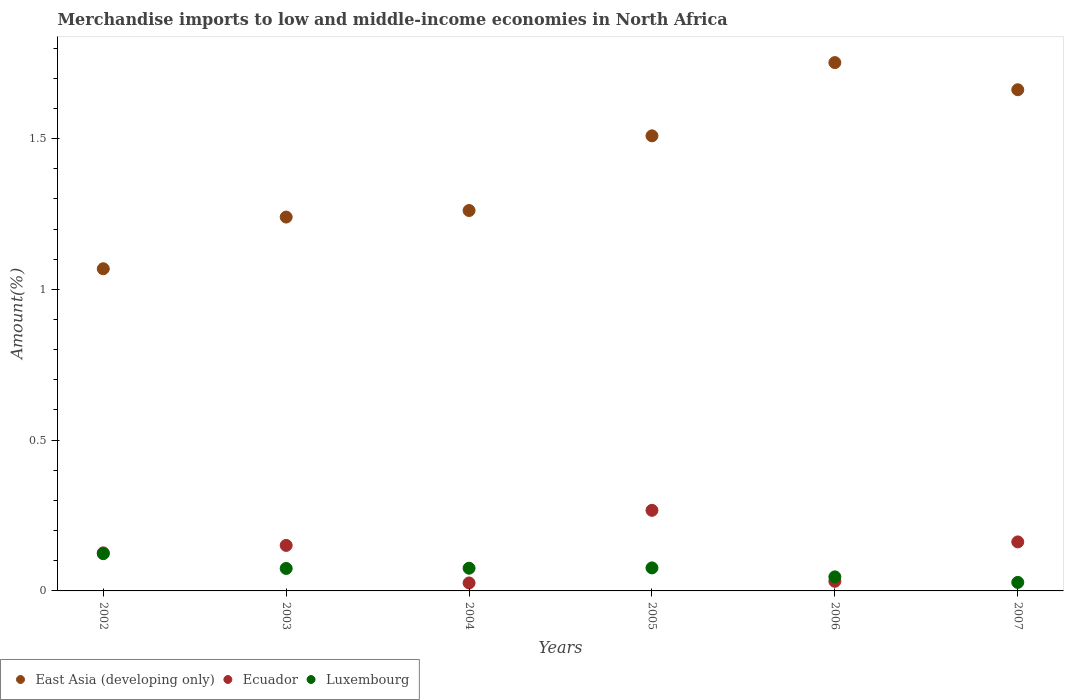How many different coloured dotlines are there?
Ensure brevity in your answer.  3. Is the number of dotlines equal to the number of legend labels?
Make the answer very short. Yes. What is the percentage of amount earned from merchandise imports in Luxembourg in 2002?
Your response must be concise. 0.12. Across all years, what is the maximum percentage of amount earned from merchandise imports in East Asia (developing only)?
Provide a short and direct response. 1.75. Across all years, what is the minimum percentage of amount earned from merchandise imports in Ecuador?
Ensure brevity in your answer.  0.03. In which year was the percentage of amount earned from merchandise imports in East Asia (developing only) maximum?
Your response must be concise. 2006. What is the total percentage of amount earned from merchandise imports in Ecuador in the graph?
Your answer should be very brief. 0.77. What is the difference between the percentage of amount earned from merchandise imports in Ecuador in 2004 and that in 2007?
Provide a succinct answer. -0.14. What is the difference between the percentage of amount earned from merchandise imports in Luxembourg in 2004 and the percentage of amount earned from merchandise imports in East Asia (developing only) in 2002?
Provide a succinct answer. -0.99. What is the average percentage of amount earned from merchandise imports in Luxembourg per year?
Offer a terse response. 0.07. In the year 2004, what is the difference between the percentage of amount earned from merchandise imports in Ecuador and percentage of amount earned from merchandise imports in East Asia (developing only)?
Make the answer very short. -1.24. In how many years, is the percentage of amount earned from merchandise imports in Ecuador greater than 0.9 %?
Provide a short and direct response. 0. What is the ratio of the percentage of amount earned from merchandise imports in Luxembourg in 2003 to that in 2006?
Provide a succinct answer. 1.6. What is the difference between the highest and the second highest percentage of amount earned from merchandise imports in Luxembourg?
Give a very brief answer. 0.05. What is the difference between the highest and the lowest percentage of amount earned from merchandise imports in Luxembourg?
Your answer should be very brief. 0.1. In how many years, is the percentage of amount earned from merchandise imports in East Asia (developing only) greater than the average percentage of amount earned from merchandise imports in East Asia (developing only) taken over all years?
Your answer should be very brief. 3. Is it the case that in every year, the sum of the percentage of amount earned from merchandise imports in East Asia (developing only) and percentage of amount earned from merchandise imports in Luxembourg  is greater than the percentage of amount earned from merchandise imports in Ecuador?
Provide a succinct answer. Yes. Is the percentage of amount earned from merchandise imports in Ecuador strictly greater than the percentage of amount earned from merchandise imports in Luxembourg over the years?
Your answer should be compact. No. Is the percentage of amount earned from merchandise imports in Luxembourg strictly less than the percentage of amount earned from merchandise imports in East Asia (developing only) over the years?
Offer a terse response. Yes. What is the difference between two consecutive major ticks on the Y-axis?
Your response must be concise. 0.5. Does the graph contain any zero values?
Your answer should be compact. No. How many legend labels are there?
Give a very brief answer. 3. How are the legend labels stacked?
Your response must be concise. Horizontal. What is the title of the graph?
Offer a very short reply. Merchandise imports to low and middle-income economies in North Africa. Does "Arab World" appear as one of the legend labels in the graph?
Offer a terse response. No. What is the label or title of the Y-axis?
Offer a terse response. Amount(%). What is the Amount(%) in East Asia (developing only) in 2002?
Offer a terse response. 1.07. What is the Amount(%) of Ecuador in 2002?
Offer a very short reply. 0.13. What is the Amount(%) in Luxembourg in 2002?
Provide a short and direct response. 0.12. What is the Amount(%) in East Asia (developing only) in 2003?
Provide a succinct answer. 1.24. What is the Amount(%) in Ecuador in 2003?
Offer a terse response. 0.15. What is the Amount(%) in Luxembourg in 2003?
Ensure brevity in your answer.  0.07. What is the Amount(%) in East Asia (developing only) in 2004?
Offer a terse response. 1.26. What is the Amount(%) in Ecuador in 2004?
Your response must be concise. 0.03. What is the Amount(%) in Luxembourg in 2004?
Offer a very short reply. 0.08. What is the Amount(%) of East Asia (developing only) in 2005?
Keep it short and to the point. 1.51. What is the Amount(%) of Ecuador in 2005?
Offer a very short reply. 0.27. What is the Amount(%) of Luxembourg in 2005?
Provide a succinct answer. 0.08. What is the Amount(%) in East Asia (developing only) in 2006?
Your answer should be compact. 1.75. What is the Amount(%) in Ecuador in 2006?
Make the answer very short. 0.03. What is the Amount(%) in Luxembourg in 2006?
Make the answer very short. 0.05. What is the Amount(%) in East Asia (developing only) in 2007?
Provide a short and direct response. 1.66. What is the Amount(%) in Ecuador in 2007?
Offer a very short reply. 0.16. What is the Amount(%) in Luxembourg in 2007?
Provide a short and direct response. 0.03. Across all years, what is the maximum Amount(%) of East Asia (developing only)?
Offer a very short reply. 1.75. Across all years, what is the maximum Amount(%) in Ecuador?
Your answer should be compact. 0.27. Across all years, what is the maximum Amount(%) of Luxembourg?
Make the answer very short. 0.12. Across all years, what is the minimum Amount(%) in East Asia (developing only)?
Offer a very short reply. 1.07. Across all years, what is the minimum Amount(%) in Ecuador?
Your answer should be very brief. 0.03. Across all years, what is the minimum Amount(%) of Luxembourg?
Offer a very short reply. 0.03. What is the total Amount(%) in East Asia (developing only) in the graph?
Give a very brief answer. 8.49. What is the total Amount(%) of Ecuador in the graph?
Your answer should be compact. 0.77. What is the total Amount(%) in Luxembourg in the graph?
Keep it short and to the point. 0.42. What is the difference between the Amount(%) in East Asia (developing only) in 2002 and that in 2003?
Give a very brief answer. -0.17. What is the difference between the Amount(%) in Ecuador in 2002 and that in 2003?
Ensure brevity in your answer.  -0.02. What is the difference between the Amount(%) of Luxembourg in 2002 and that in 2003?
Your response must be concise. 0.05. What is the difference between the Amount(%) of East Asia (developing only) in 2002 and that in 2004?
Provide a short and direct response. -0.19. What is the difference between the Amount(%) of Ecuador in 2002 and that in 2004?
Your response must be concise. 0.1. What is the difference between the Amount(%) of Luxembourg in 2002 and that in 2004?
Your response must be concise. 0.05. What is the difference between the Amount(%) in East Asia (developing only) in 2002 and that in 2005?
Provide a succinct answer. -0.44. What is the difference between the Amount(%) in Ecuador in 2002 and that in 2005?
Your answer should be compact. -0.14. What is the difference between the Amount(%) in Luxembourg in 2002 and that in 2005?
Your answer should be compact. 0.05. What is the difference between the Amount(%) in East Asia (developing only) in 2002 and that in 2006?
Your answer should be very brief. -0.68. What is the difference between the Amount(%) in Ecuador in 2002 and that in 2006?
Ensure brevity in your answer.  0.09. What is the difference between the Amount(%) in Luxembourg in 2002 and that in 2006?
Ensure brevity in your answer.  0.08. What is the difference between the Amount(%) in East Asia (developing only) in 2002 and that in 2007?
Offer a terse response. -0.59. What is the difference between the Amount(%) in Ecuador in 2002 and that in 2007?
Your answer should be compact. -0.04. What is the difference between the Amount(%) in Luxembourg in 2002 and that in 2007?
Offer a very short reply. 0.1. What is the difference between the Amount(%) in East Asia (developing only) in 2003 and that in 2004?
Keep it short and to the point. -0.02. What is the difference between the Amount(%) of Ecuador in 2003 and that in 2004?
Make the answer very short. 0.12. What is the difference between the Amount(%) in Luxembourg in 2003 and that in 2004?
Your response must be concise. -0. What is the difference between the Amount(%) of East Asia (developing only) in 2003 and that in 2005?
Make the answer very short. -0.27. What is the difference between the Amount(%) in Ecuador in 2003 and that in 2005?
Your answer should be very brief. -0.12. What is the difference between the Amount(%) in Luxembourg in 2003 and that in 2005?
Your response must be concise. -0. What is the difference between the Amount(%) of East Asia (developing only) in 2003 and that in 2006?
Offer a terse response. -0.51. What is the difference between the Amount(%) of Ecuador in 2003 and that in 2006?
Provide a succinct answer. 0.12. What is the difference between the Amount(%) of Luxembourg in 2003 and that in 2006?
Offer a terse response. 0.03. What is the difference between the Amount(%) in East Asia (developing only) in 2003 and that in 2007?
Offer a very short reply. -0.42. What is the difference between the Amount(%) in Ecuador in 2003 and that in 2007?
Your answer should be very brief. -0.01. What is the difference between the Amount(%) of Luxembourg in 2003 and that in 2007?
Offer a very short reply. 0.05. What is the difference between the Amount(%) of East Asia (developing only) in 2004 and that in 2005?
Your answer should be very brief. -0.25. What is the difference between the Amount(%) of Ecuador in 2004 and that in 2005?
Your response must be concise. -0.24. What is the difference between the Amount(%) of Luxembourg in 2004 and that in 2005?
Keep it short and to the point. -0. What is the difference between the Amount(%) in East Asia (developing only) in 2004 and that in 2006?
Give a very brief answer. -0.49. What is the difference between the Amount(%) in Ecuador in 2004 and that in 2006?
Provide a short and direct response. -0.01. What is the difference between the Amount(%) in Luxembourg in 2004 and that in 2006?
Ensure brevity in your answer.  0.03. What is the difference between the Amount(%) of East Asia (developing only) in 2004 and that in 2007?
Offer a very short reply. -0.4. What is the difference between the Amount(%) of Ecuador in 2004 and that in 2007?
Ensure brevity in your answer.  -0.14. What is the difference between the Amount(%) of Luxembourg in 2004 and that in 2007?
Offer a very short reply. 0.05. What is the difference between the Amount(%) of East Asia (developing only) in 2005 and that in 2006?
Keep it short and to the point. -0.24. What is the difference between the Amount(%) in Ecuador in 2005 and that in 2006?
Offer a terse response. 0.24. What is the difference between the Amount(%) of Luxembourg in 2005 and that in 2006?
Your response must be concise. 0.03. What is the difference between the Amount(%) in East Asia (developing only) in 2005 and that in 2007?
Ensure brevity in your answer.  -0.15. What is the difference between the Amount(%) of Ecuador in 2005 and that in 2007?
Give a very brief answer. 0.1. What is the difference between the Amount(%) of Luxembourg in 2005 and that in 2007?
Keep it short and to the point. 0.05. What is the difference between the Amount(%) in East Asia (developing only) in 2006 and that in 2007?
Your response must be concise. 0.09. What is the difference between the Amount(%) in Ecuador in 2006 and that in 2007?
Your answer should be compact. -0.13. What is the difference between the Amount(%) in Luxembourg in 2006 and that in 2007?
Offer a terse response. 0.02. What is the difference between the Amount(%) of East Asia (developing only) in 2002 and the Amount(%) of Ecuador in 2003?
Your answer should be compact. 0.92. What is the difference between the Amount(%) in Ecuador in 2002 and the Amount(%) in Luxembourg in 2003?
Make the answer very short. 0.05. What is the difference between the Amount(%) in East Asia (developing only) in 2002 and the Amount(%) in Ecuador in 2004?
Offer a very short reply. 1.04. What is the difference between the Amount(%) of East Asia (developing only) in 2002 and the Amount(%) of Luxembourg in 2004?
Keep it short and to the point. 0.99. What is the difference between the Amount(%) of Ecuador in 2002 and the Amount(%) of Luxembourg in 2004?
Your answer should be compact. 0.05. What is the difference between the Amount(%) in East Asia (developing only) in 2002 and the Amount(%) in Ecuador in 2005?
Offer a very short reply. 0.8. What is the difference between the Amount(%) of East Asia (developing only) in 2002 and the Amount(%) of Luxembourg in 2005?
Your answer should be compact. 0.99. What is the difference between the Amount(%) of Ecuador in 2002 and the Amount(%) of Luxembourg in 2005?
Your answer should be compact. 0.05. What is the difference between the Amount(%) in East Asia (developing only) in 2002 and the Amount(%) in Ecuador in 2006?
Ensure brevity in your answer.  1.04. What is the difference between the Amount(%) in East Asia (developing only) in 2002 and the Amount(%) in Luxembourg in 2006?
Ensure brevity in your answer.  1.02. What is the difference between the Amount(%) in Ecuador in 2002 and the Amount(%) in Luxembourg in 2006?
Make the answer very short. 0.08. What is the difference between the Amount(%) of East Asia (developing only) in 2002 and the Amount(%) of Ecuador in 2007?
Provide a succinct answer. 0.91. What is the difference between the Amount(%) in East Asia (developing only) in 2002 and the Amount(%) in Luxembourg in 2007?
Offer a terse response. 1.04. What is the difference between the Amount(%) of Ecuador in 2002 and the Amount(%) of Luxembourg in 2007?
Offer a very short reply. 0.1. What is the difference between the Amount(%) of East Asia (developing only) in 2003 and the Amount(%) of Ecuador in 2004?
Make the answer very short. 1.21. What is the difference between the Amount(%) of East Asia (developing only) in 2003 and the Amount(%) of Luxembourg in 2004?
Your response must be concise. 1.16. What is the difference between the Amount(%) in Ecuador in 2003 and the Amount(%) in Luxembourg in 2004?
Provide a short and direct response. 0.08. What is the difference between the Amount(%) in East Asia (developing only) in 2003 and the Amount(%) in Ecuador in 2005?
Your answer should be very brief. 0.97. What is the difference between the Amount(%) in East Asia (developing only) in 2003 and the Amount(%) in Luxembourg in 2005?
Ensure brevity in your answer.  1.16. What is the difference between the Amount(%) in Ecuador in 2003 and the Amount(%) in Luxembourg in 2005?
Ensure brevity in your answer.  0.07. What is the difference between the Amount(%) in East Asia (developing only) in 2003 and the Amount(%) in Ecuador in 2006?
Your answer should be very brief. 1.21. What is the difference between the Amount(%) of East Asia (developing only) in 2003 and the Amount(%) of Luxembourg in 2006?
Your response must be concise. 1.19. What is the difference between the Amount(%) in Ecuador in 2003 and the Amount(%) in Luxembourg in 2006?
Offer a very short reply. 0.1. What is the difference between the Amount(%) of East Asia (developing only) in 2003 and the Amount(%) of Ecuador in 2007?
Provide a succinct answer. 1.08. What is the difference between the Amount(%) in East Asia (developing only) in 2003 and the Amount(%) in Luxembourg in 2007?
Offer a terse response. 1.21. What is the difference between the Amount(%) of Ecuador in 2003 and the Amount(%) of Luxembourg in 2007?
Make the answer very short. 0.12. What is the difference between the Amount(%) in East Asia (developing only) in 2004 and the Amount(%) in Luxembourg in 2005?
Offer a very short reply. 1.19. What is the difference between the Amount(%) of Ecuador in 2004 and the Amount(%) of Luxembourg in 2005?
Your answer should be very brief. -0.05. What is the difference between the Amount(%) in East Asia (developing only) in 2004 and the Amount(%) in Ecuador in 2006?
Ensure brevity in your answer.  1.23. What is the difference between the Amount(%) in East Asia (developing only) in 2004 and the Amount(%) in Luxembourg in 2006?
Offer a terse response. 1.21. What is the difference between the Amount(%) in Ecuador in 2004 and the Amount(%) in Luxembourg in 2006?
Your response must be concise. -0.02. What is the difference between the Amount(%) of East Asia (developing only) in 2004 and the Amount(%) of Ecuador in 2007?
Your answer should be compact. 1.1. What is the difference between the Amount(%) in East Asia (developing only) in 2004 and the Amount(%) in Luxembourg in 2007?
Provide a short and direct response. 1.23. What is the difference between the Amount(%) of Ecuador in 2004 and the Amount(%) of Luxembourg in 2007?
Provide a short and direct response. -0. What is the difference between the Amount(%) of East Asia (developing only) in 2005 and the Amount(%) of Ecuador in 2006?
Give a very brief answer. 1.48. What is the difference between the Amount(%) in East Asia (developing only) in 2005 and the Amount(%) in Luxembourg in 2006?
Provide a succinct answer. 1.46. What is the difference between the Amount(%) of Ecuador in 2005 and the Amount(%) of Luxembourg in 2006?
Provide a succinct answer. 0.22. What is the difference between the Amount(%) in East Asia (developing only) in 2005 and the Amount(%) in Ecuador in 2007?
Give a very brief answer. 1.35. What is the difference between the Amount(%) in East Asia (developing only) in 2005 and the Amount(%) in Luxembourg in 2007?
Your response must be concise. 1.48. What is the difference between the Amount(%) in Ecuador in 2005 and the Amount(%) in Luxembourg in 2007?
Make the answer very short. 0.24. What is the difference between the Amount(%) in East Asia (developing only) in 2006 and the Amount(%) in Ecuador in 2007?
Your answer should be very brief. 1.59. What is the difference between the Amount(%) in East Asia (developing only) in 2006 and the Amount(%) in Luxembourg in 2007?
Keep it short and to the point. 1.72. What is the difference between the Amount(%) of Ecuador in 2006 and the Amount(%) of Luxembourg in 2007?
Provide a succinct answer. 0. What is the average Amount(%) of East Asia (developing only) per year?
Your answer should be compact. 1.42. What is the average Amount(%) of Ecuador per year?
Provide a short and direct response. 0.13. What is the average Amount(%) in Luxembourg per year?
Your answer should be very brief. 0.07. In the year 2002, what is the difference between the Amount(%) of East Asia (developing only) and Amount(%) of Ecuador?
Offer a very short reply. 0.94. In the year 2002, what is the difference between the Amount(%) of East Asia (developing only) and Amount(%) of Luxembourg?
Provide a succinct answer. 0.94. In the year 2002, what is the difference between the Amount(%) in Ecuador and Amount(%) in Luxembourg?
Provide a short and direct response. 0. In the year 2003, what is the difference between the Amount(%) of East Asia (developing only) and Amount(%) of Ecuador?
Keep it short and to the point. 1.09. In the year 2003, what is the difference between the Amount(%) in East Asia (developing only) and Amount(%) in Luxembourg?
Provide a succinct answer. 1.17. In the year 2003, what is the difference between the Amount(%) of Ecuador and Amount(%) of Luxembourg?
Ensure brevity in your answer.  0.08. In the year 2004, what is the difference between the Amount(%) of East Asia (developing only) and Amount(%) of Ecuador?
Provide a short and direct response. 1.24. In the year 2004, what is the difference between the Amount(%) in East Asia (developing only) and Amount(%) in Luxembourg?
Provide a short and direct response. 1.19. In the year 2004, what is the difference between the Amount(%) in Ecuador and Amount(%) in Luxembourg?
Ensure brevity in your answer.  -0.05. In the year 2005, what is the difference between the Amount(%) of East Asia (developing only) and Amount(%) of Ecuador?
Your answer should be compact. 1.24. In the year 2005, what is the difference between the Amount(%) in East Asia (developing only) and Amount(%) in Luxembourg?
Make the answer very short. 1.43. In the year 2005, what is the difference between the Amount(%) in Ecuador and Amount(%) in Luxembourg?
Provide a succinct answer. 0.19. In the year 2006, what is the difference between the Amount(%) in East Asia (developing only) and Amount(%) in Ecuador?
Keep it short and to the point. 1.72. In the year 2006, what is the difference between the Amount(%) of East Asia (developing only) and Amount(%) of Luxembourg?
Ensure brevity in your answer.  1.71. In the year 2006, what is the difference between the Amount(%) of Ecuador and Amount(%) of Luxembourg?
Keep it short and to the point. -0.01. In the year 2007, what is the difference between the Amount(%) of East Asia (developing only) and Amount(%) of Ecuador?
Keep it short and to the point. 1.5. In the year 2007, what is the difference between the Amount(%) in East Asia (developing only) and Amount(%) in Luxembourg?
Ensure brevity in your answer.  1.63. In the year 2007, what is the difference between the Amount(%) in Ecuador and Amount(%) in Luxembourg?
Provide a short and direct response. 0.13. What is the ratio of the Amount(%) of East Asia (developing only) in 2002 to that in 2003?
Provide a short and direct response. 0.86. What is the ratio of the Amount(%) in Ecuador in 2002 to that in 2003?
Make the answer very short. 0.84. What is the ratio of the Amount(%) in Luxembourg in 2002 to that in 2003?
Give a very brief answer. 1.66. What is the ratio of the Amount(%) of East Asia (developing only) in 2002 to that in 2004?
Your answer should be very brief. 0.85. What is the ratio of the Amount(%) in Ecuador in 2002 to that in 2004?
Your response must be concise. 4.77. What is the ratio of the Amount(%) in Luxembourg in 2002 to that in 2004?
Give a very brief answer. 1.64. What is the ratio of the Amount(%) of East Asia (developing only) in 2002 to that in 2005?
Ensure brevity in your answer.  0.71. What is the ratio of the Amount(%) of Ecuador in 2002 to that in 2005?
Make the answer very short. 0.47. What is the ratio of the Amount(%) in Luxembourg in 2002 to that in 2005?
Your answer should be very brief. 1.62. What is the ratio of the Amount(%) of East Asia (developing only) in 2002 to that in 2006?
Provide a succinct answer. 0.61. What is the ratio of the Amount(%) in Ecuador in 2002 to that in 2006?
Offer a terse response. 3.96. What is the ratio of the Amount(%) of Luxembourg in 2002 to that in 2006?
Ensure brevity in your answer.  2.65. What is the ratio of the Amount(%) in East Asia (developing only) in 2002 to that in 2007?
Offer a terse response. 0.64. What is the ratio of the Amount(%) in Ecuador in 2002 to that in 2007?
Keep it short and to the point. 0.78. What is the ratio of the Amount(%) of Luxembourg in 2002 to that in 2007?
Keep it short and to the point. 4.37. What is the ratio of the Amount(%) in East Asia (developing only) in 2003 to that in 2004?
Your response must be concise. 0.98. What is the ratio of the Amount(%) in Ecuador in 2003 to that in 2004?
Your answer should be compact. 5.71. What is the ratio of the Amount(%) in Luxembourg in 2003 to that in 2004?
Offer a very short reply. 0.99. What is the ratio of the Amount(%) of East Asia (developing only) in 2003 to that in 2005?
Your answer should be very brief. 0.82. What is the ratio of the Amount(%) in Ecuador in 2003 to that in 2005?
Provide a succinct answer. 0.56. What is the ratio of the Amount(%) in Luxembourg in 2003 to that in 2005?
Your answer should be compact. 0.98. What is the ratio of the Amount(%) of East Asia (developing only) in 2003 to that in 2006?
Offer a terse response. 0.71. What is the ratio of the Amount(%) in Ecuador in 2003 to that in 2006?
Give a very brief answer. 4.74. What is the ratio of the Amount(%) of Luxembourg in 2003 to that in 2006?
Your answer should be compact. 1.6. What is the ratio of the Amount(%) of East Asia (developing only) in 2003 to that in 2007?
Ensure brevity in your answer.  0.75. What is the ratio of the Amount(%) of Ecuador in 2003 to that in 2007?
Provide a succinct answer. 0.93. What is the ratio of the Amount(%) of Luxembourg in 2003 to that in 2007?
Offer a very short reply. 2.64. What is the ratio of the Amount(%) of East Asia (developing only) in 2004 to that in 2005?
Provide a short and direct response. 0.84. What is the ratio of the Amount(%) in Ecuador in 2004 to that in 2005?
Offer a terse response. 0.1. What is the ratio of the Amount(%) in Luxembourg in 2004 to that in 2005?
Give a very brief answer. 0.99. What is the ratio of the Amount(%) in East Asia (developing only) in 2004 to that in 2006?
Keep it short and to the point. 0.72. What is the ratio of the Amount(%) in Ecuador in 2004 to that in 2006?
Ensure brevity in your answer.  0.83. What is the ratio of the Amount(%) of Luxembourg in 2004 to that in 2006?
Your answer should be very brief. 1.61. What is the ratio of the Amount(%) of East Asia (developing only) in 2004 to that in 2007?
Keep it short and to the point. 0.76. What is the ratio of the Amount(%) in Ecuador in 2004 to that in 2007?
Give a very brief answer. 0.16. What is the ratio of the Amount(%) of Luxembourg in 2004 to that in 2007?
Your answer should be compact. 2.67. What is the ratio of the Amount(%) in East Asia (developing only) in 2005 to that in 2006?
Provide a short and direct response. 0.86. What is the ratio of the Amount(%) in Ecuador in 2005 to that in 2006?
Your response must be concise. 8.39. What is the ratio of the Amount(%) of Luxembourg in 2005 to that in 2006?
Offer a terse response. 1.64. What is the ratio of the Amount(%) in East Asia (developing only) in 2005 to that in 2007?
Provide a short and direct response. 0.91. What is the ratio of the Amount(%) of Ecuador in 2005 to that in 2007?
Provide a short and direct response. 1.64. What is the ratio of the Amount(%) of Luxembourg in 2005 to that in 2007?
Give a very brief answer. 2.7. What is the ratio of the Amount(%) of East Asia (developing only) in 2006 to that in 2007?
Ensure brevity in your answer.  1.05. What is the ratio of the Amount(%) in Ecuador in 2006 to that in 2007?
Provide a short and direct response. 0.2. What is the ratio of the Amount(%) in Luxembourg in 2006 to that in 2007?
Give a very brief answer. 1.65. What is the difference between the highest and the second highest Amount(%) in East Asia (developing only)?
Provide a succinct answer. 0.09. What is the difference between the highest and the second highest Amount(%) of Ecuador?
Offer a very short reply. 0.1. What is the difference between the highest and the second highest Amount(%) in Luxembourg?
Your answer should be compact. 0.05. What is the difference between the highest and the lowest Amount(%) in East Asia (developing only)?
Your response must be concise. 0.68. What is the difference between the highest and the lowest Amount(%) in Ecuador?
Provide a succinct answer. 0.24. What is the difference between the highest and the lowest Amount(%) in Luxembourg?
Make the answer very short. 0.1. 